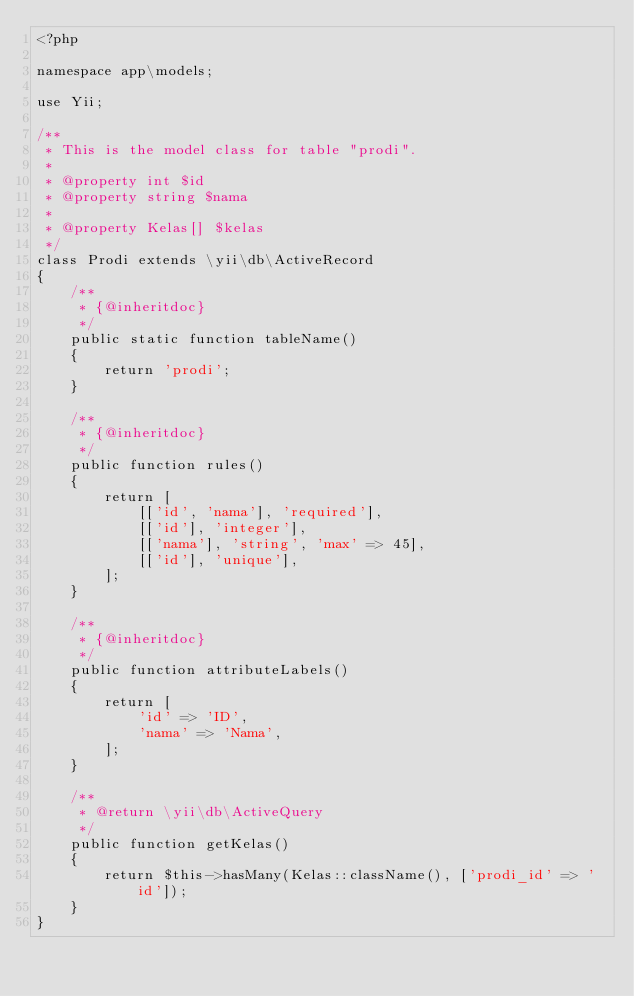Convert code to text. <code><loc_0><loc_0><loc_500><loc_500><_PHP_><?php

namespace app\models;

use Yii;

/**
 * This is the model class for table "prodi".
 *
 * @property int $id
 * @property string $nama
 *
 * @property Kelas[] $kelas
 */
class Prodi extends \yii\db\ActiveRecord
{
    /**
     * {@inheritdoc}
     */
    public static function tableName()
    {
        return 'prodi';
    }

    /**
     * {@inheritdoc}
     */
    public function rules()
    {
        return [
            [['id', 'nama'], 'required'],
            [['id'], 'integer'],
            [['nama'], 'string', 'max' => 45],
            [['id'], 'unique'],
        ];
    }

    /**
     * {@inheritdoc}
     */
    public function attributeLabels()
    {
        return [
            'id' => 'ID',
            'nama' => 'Nama',
        ];
    }

    /**
     * @return \yii\db\ActiveQuery
     */
    public function getKelas()
    {
        return $this->hasMany(Kelas::className(), ['prodi_id' => 'id']);
    }
}
</code> 